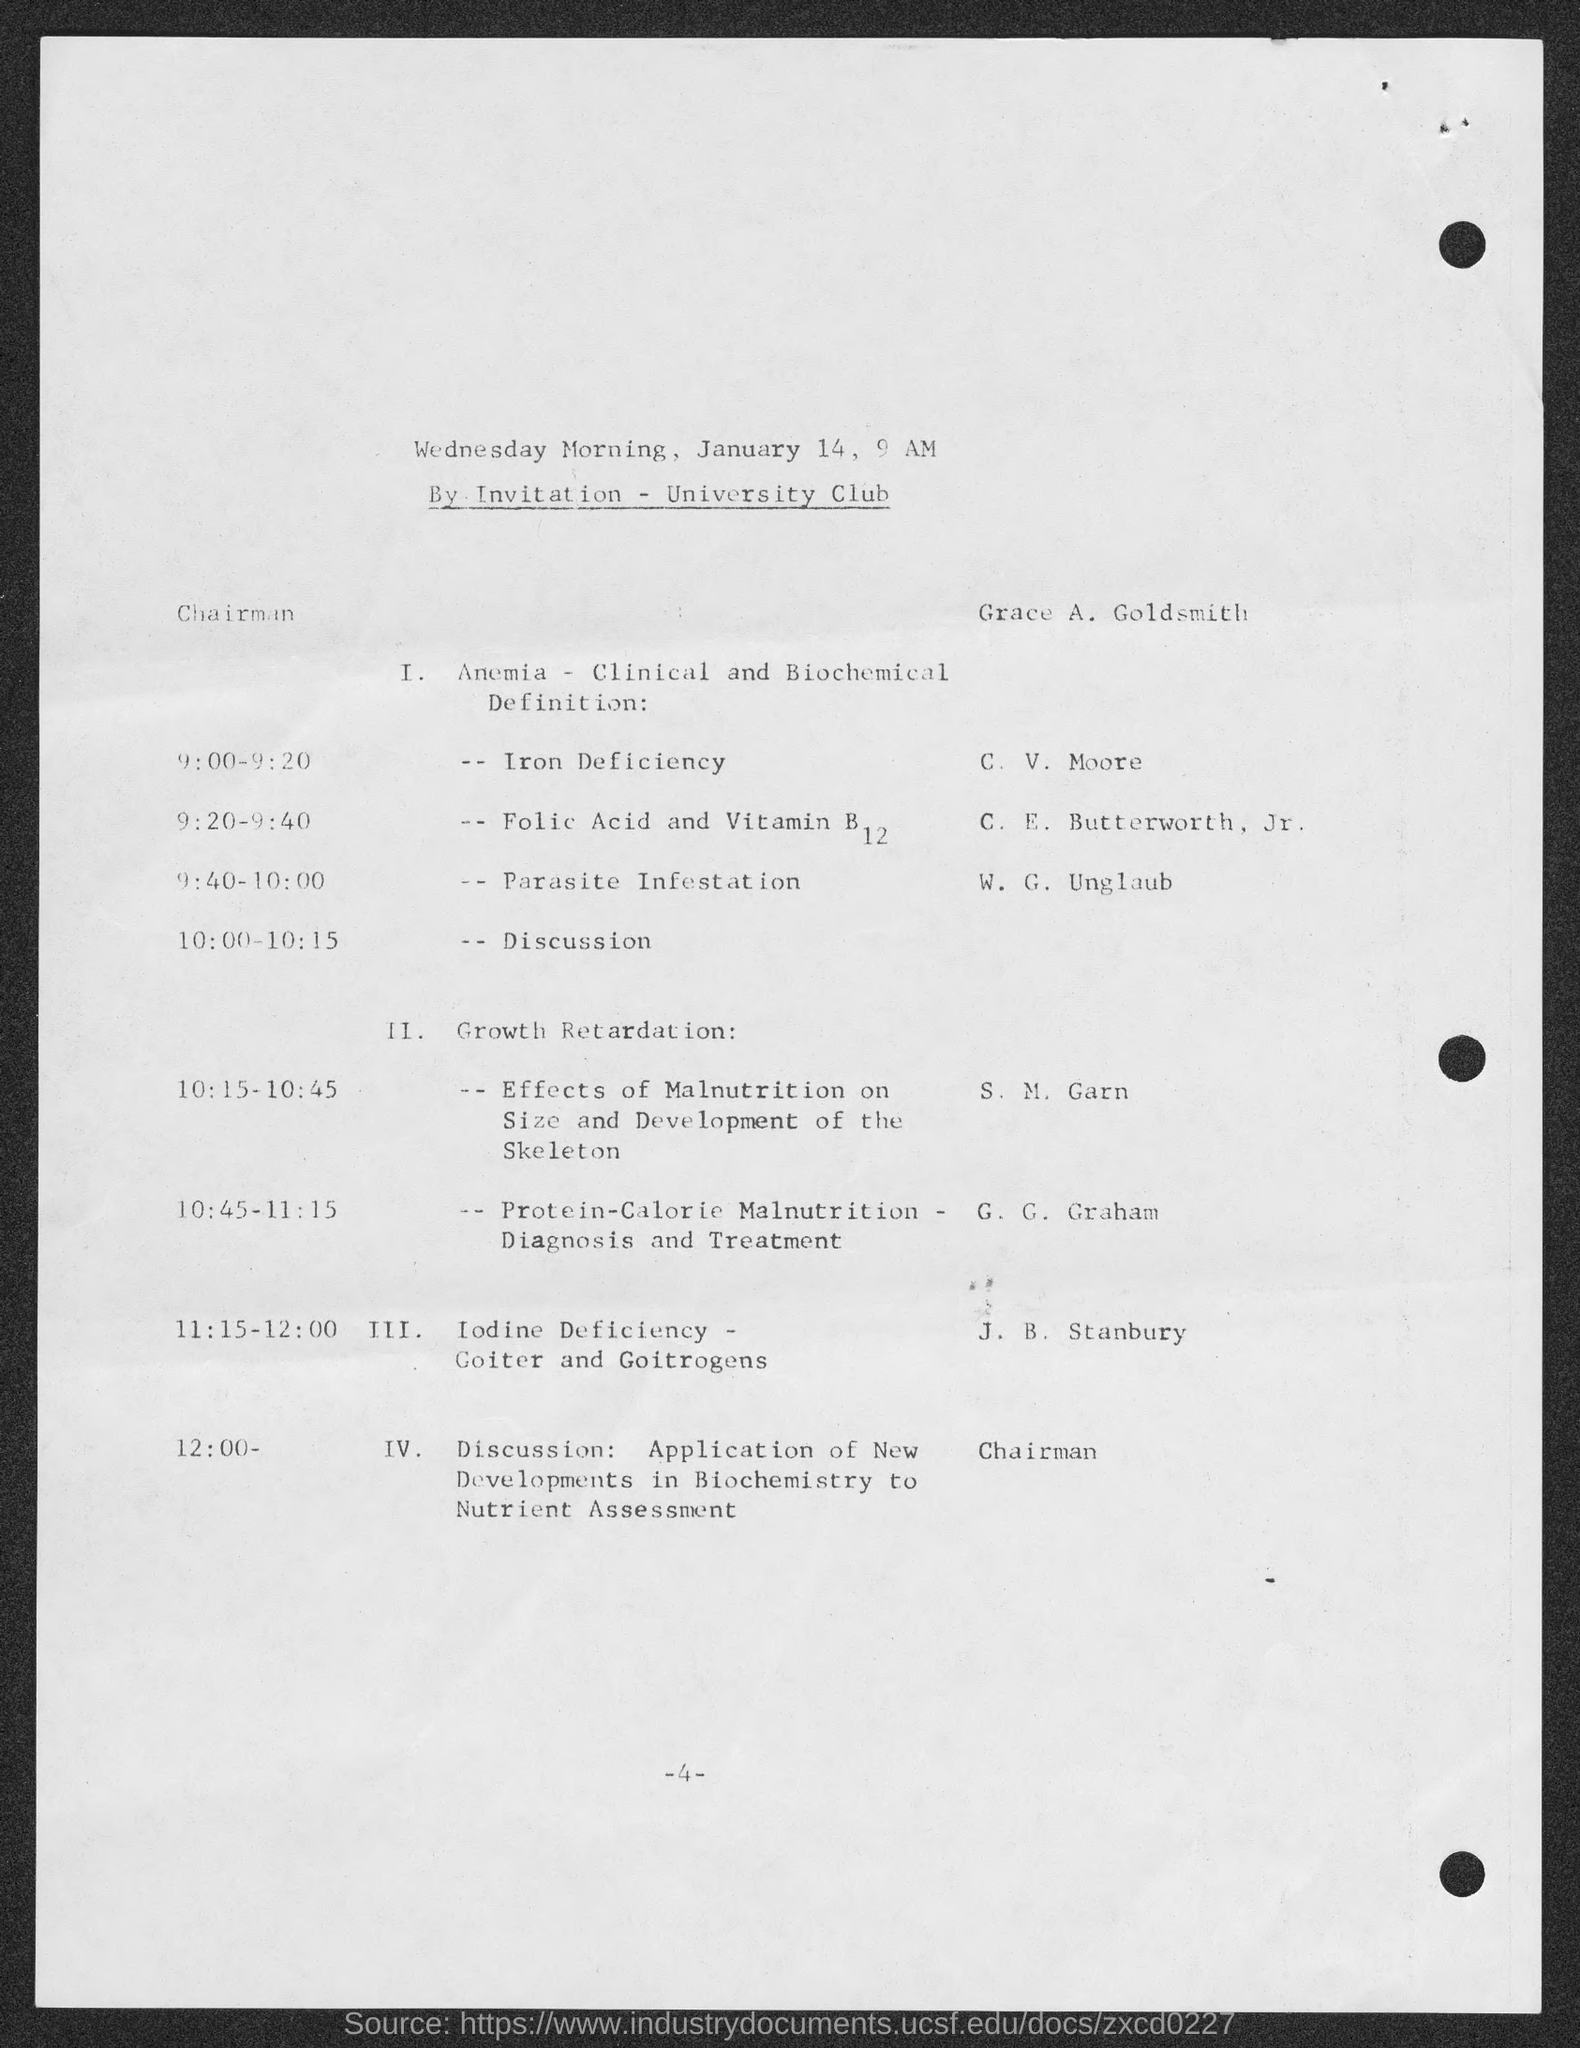What is the number at bottom of the page ?
Give a very brief answer. -4-. 